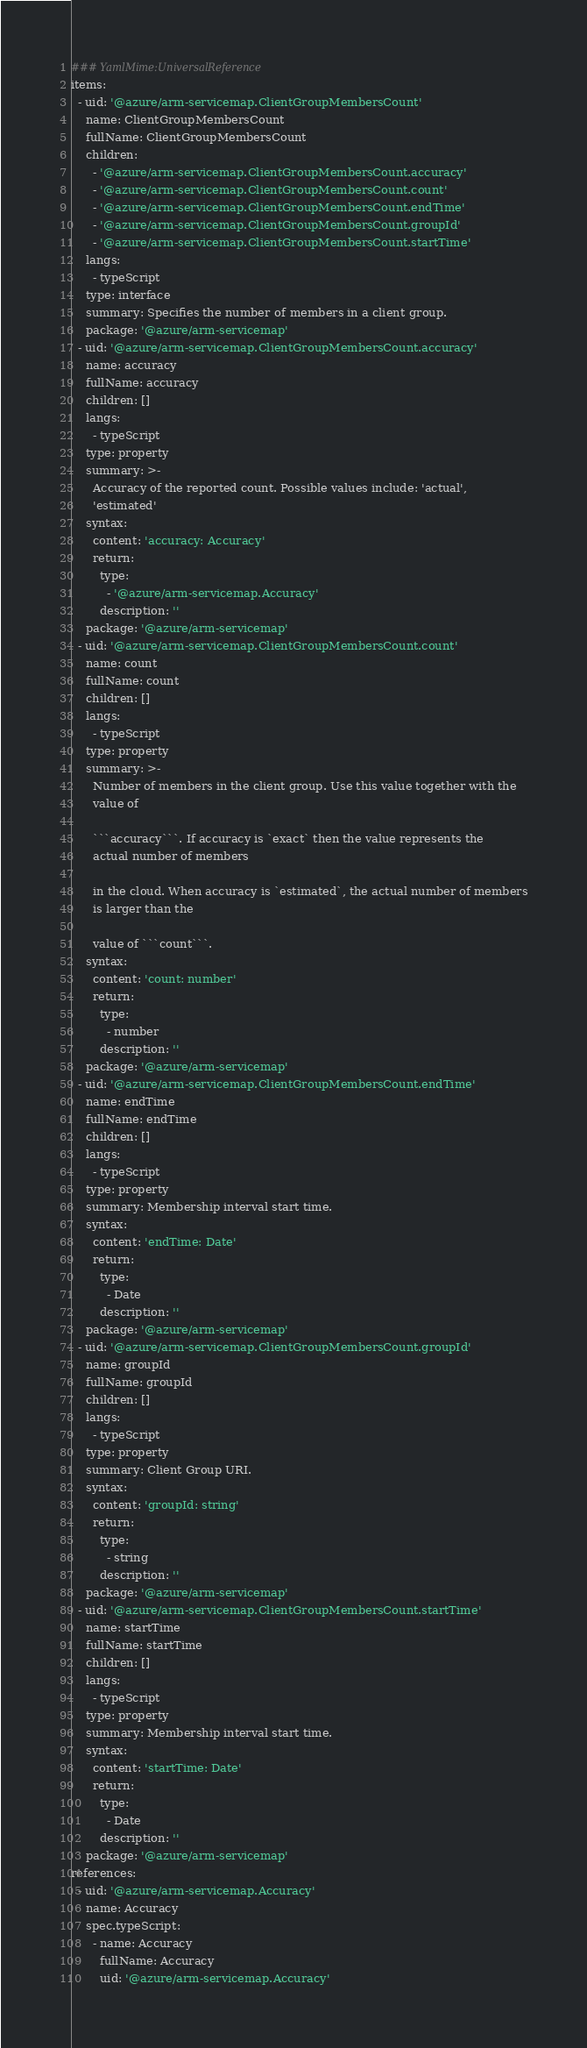<code> <loc_0><loc_0><loc_500><loc_500><_YAML_>### YamlMime:UniversalReference
items:
  - uid: '@azure/arm-servicemap.ClientGroupMembersCount'
    name: ClientGroupMembersCount
    fullName: ClientGroupMembersCount
    children:
      - '@azure/arm-servicemap.ClientGroupMembersCount.accuracy'
      - '@azure/arm-servicemap.ClientGroupMembersCount.count'
      - '@azure/arm-servicemap.ClientGroupMembersCount.endTime'
      - '@azure/arm-servicemap.ClientGroupMembersCount.groupId'
      - '@azure/arm-servicemap.ClientGroupMembersCount.startTime'
    langs:
      - typeScript
    type: interface
    summary: Specifies the number of members in a client group.
    package: '@azure/arm-servicemap'
  - uid: '@azure/arm-servicemap.ClientGroupMembersCount.accuracy'
    name: accuracy
    fullName: accuracy
    children: []
    langs:
      - typeScript
    type: property
    summary: >-
      Accuracy of the reported count. Possible values include: 'actual',
      'estimated'
    syntax:
      content: 'accuracy: Accuracy'
      return:
        type:
          - '@azure/arm-servicemap.Accuracy'
        description: ''
    package: '@azure/arm-servicemap'
  - uid: '@azure/arm-servicemap.ClientGroupMembersCount.count'
    name: count
    fullName: count
    children: []
    langs:
      - typeScript
    type: property
    summary: >-
      Number of members in the client group. Use this value together with the
      value of

      ```accuracy```. If accuracy is `exact` then the value represents the
      actual number of members

      in the cloud. When accuracy is `estimated`, the actual number of members
      is larger than the

      value of ```count```.
    syntax:
      content: 'count: number'
      return:
        type:
          - number
        description: ''
    package: '@azure/arm-servicemap'
  - uid: '@azure/arm-servicemap.ClientGroupMembersCount.endTime'
    name: endTime
    fullName: endTime
    children: []
    langs:
      - typeScript
    type: property
    summary: Membership interval start time.
    syntax:
      content: 'endTime: Date'
      return:
        type:
          - Date
        description: ''
    package: '@azure/arm-servicemap'
  - uid: '@azure/arm-servicemap.ClientGroupMembersCount.groupId'
    name: groupId
    fullName: groupId
    children: []
    langs:
      - typeScript
    type: property
    summary: Client Group URI.
    syntax:
      content: 'groupId: string'
      return:
        type:
          - string
        description: ''
    package: '@azure/arm-servicemap'
  - uid: '@azure/arm-servicemap.ClientGroupMembersCount.startTime'
    name: startTime
    fullName: startTime
    children: []
    langs:
      - typeScript
    type: property
    summary: Membership interval start time.
    syntax:
      content: 'startTime: Date'
      return:
        type:
          - Date
        description: ''
    package: '@azure/arm-servicemap'
references:
  - uid: '@azure/arm-servicemap.Accuracy'
    name: Accuracy
    spec.typeScript:
      - name: Accuracy
        fullName: Accuracy
        uid: '@azure/arm-servicemap.Accuracy'
</code> 